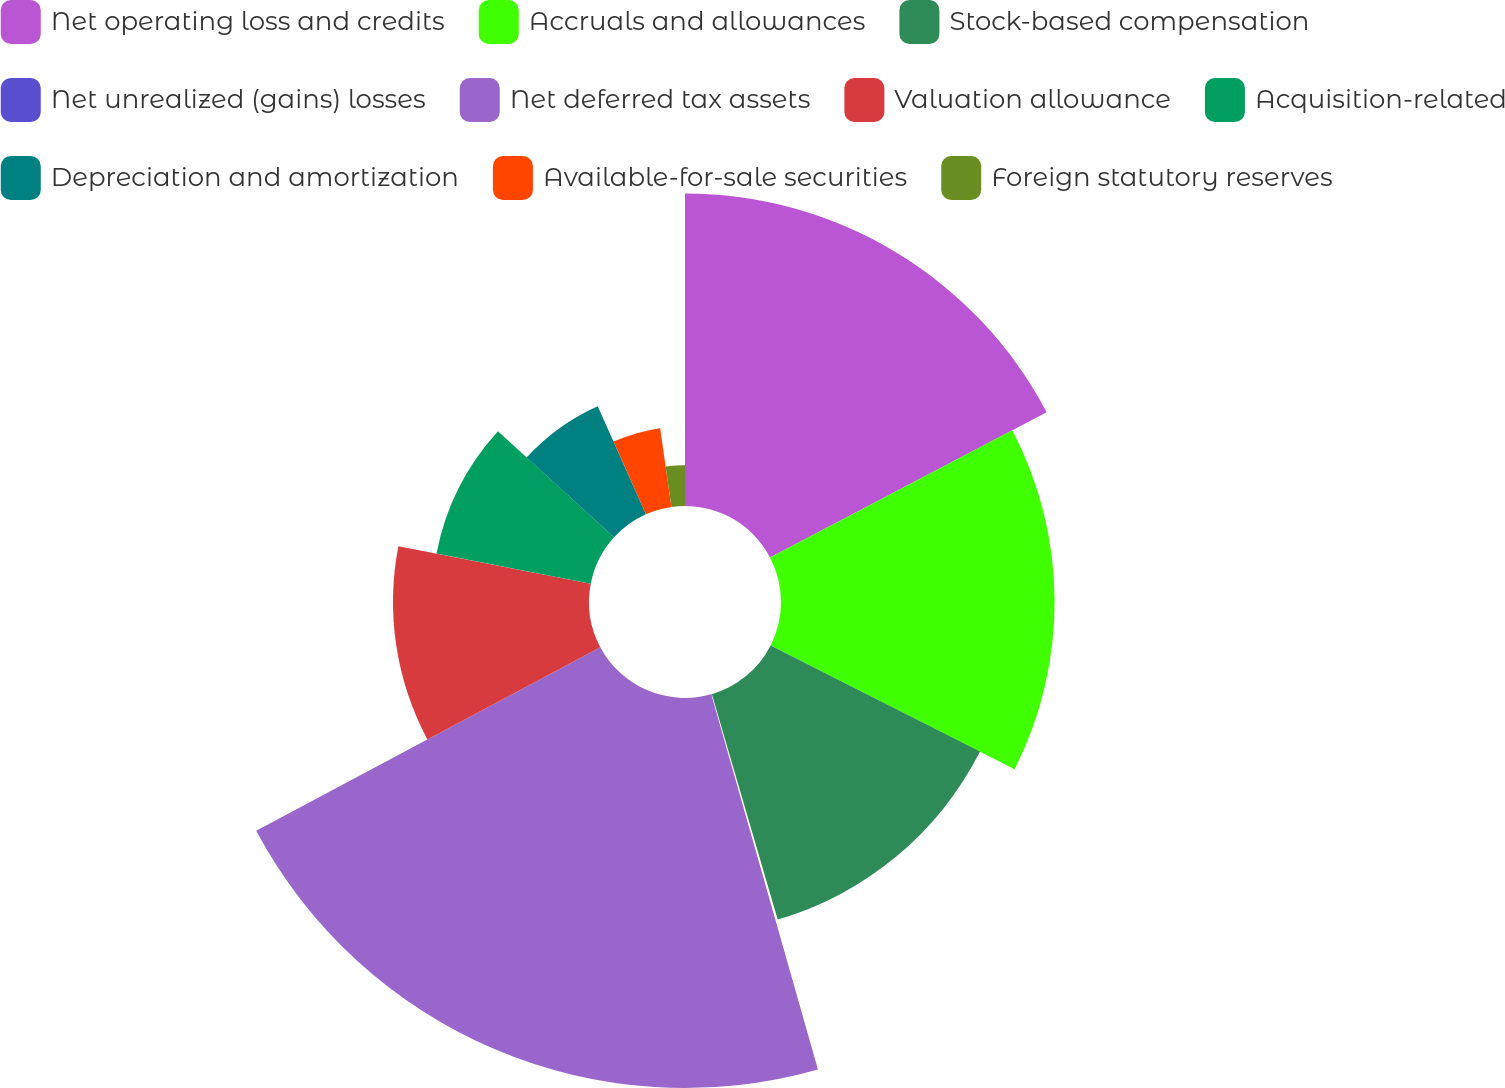<chart> <loc_0><loc_0><loc_500><loc_500><pie_chart><fcel>Net operating loss and credits<fcel>Accruals and allowances<fcel>Stock-based compensation<fcel>Net unrealized (gains) losses<fcel>Net deferred tax assets<fcel>Valuation allowance<fcel>Acquisition-related<fcel>Depreciation and amortization<fcel>Available-for-sale securities<fcel>Foreign statutory reserves<nl><fcel>17.31%<fcel>15.16%<fcel>13.01%<fcel>0.11%<fcel>21.61%<fcel>10.86%<fcel>8.71%<fcel>6.56%<fcel>4.41%<fcel>2.26%<nl></chart> 